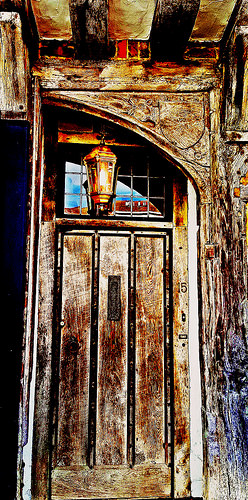<image>
Is the light in front of the window? Yes. The light is positioned in front of the window, appearing closer to the camera viewpoint. 